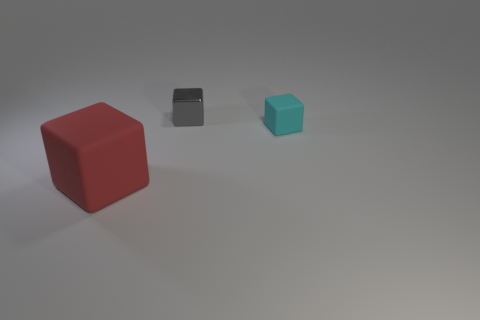Subtract all small blocks. How many blocks are left? 1 Subtract 1 blocks. How many blocks are left? 2 Add 3 small rubber objects. How many objects exist? 6 Add 3 cyan objects. How many cyan objects exist? 4 Subtract 1 red cubes. How many objects are left? 2 Subtract all red blocks. Subtract all small gray blocks. How many objects are left? 1 Add 1 big red matte objects. How many big red matte objects are left? 2 